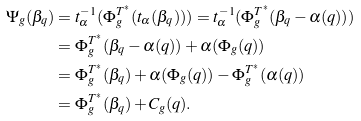<formula> <loc_0><loc_0><loc_500><loc_500>\Psi _ { g } ( \beta _ { q } ) & = t _ { \alpha } ^ { - 1 } ( \Phi _ { g } ^ { T ^ { * } } ( t _ { \alpha } ( \beta _ { q } ) ) ) = t _ { \alpha } ^ { - 1 } ( \Phi _ { g } ^ { T ^ { * } } ( \beta _ { q } - \alpha ( q ) ) ) \\ & = \Phi _ { g } ^ { T ^ { * } } ( \beta _ { q } - \alpha ( q ) ) + \alpha ( \Phi _ { g } ( q ) ) \\ & = \Phi _ { g } ^ { T ^ { * } } ( \beta _ { q } ) + \alpha ( \Phi _ { g } ( q ) ) - \Phi _ { g } ^ { T ^ { * } } ( \alpha ( q ) ) \\ & = \Phi _ { g } ^ { T ^ { * } } ( \beta _ { q } ) + C _ { g } ( q ) .</formula> 